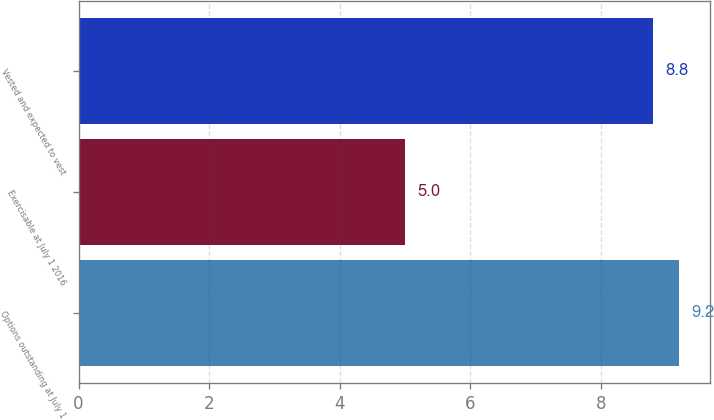<chart> <loc_0><loc_0><loc_500><loc_500><bar_chart><fcel>Options outstanding at July 1<fcel>Exercisable at July 1 2016<fcel>Vested and expected to vest<nl><fcel>9.2<fcel>5<fcel>8.8<nl></chart> 